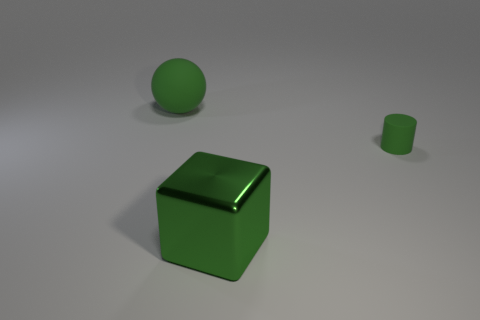Add 3 green cylinders. How many objects exist? 6 Subtract all blocks. How many objects are left? 2 Add 2 small rubber cylinders. How many small rubber cylinders exist? 3 Subtract 1 green cylinders. How many objects are left? 2 Subtract all tiny green matte balls. Subtract all big things. How many objects are left? 1 Add 1 big spheres. How many big spheres are left? 2 